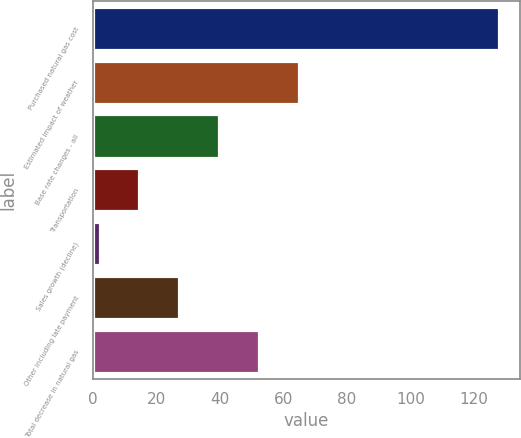<chart> <loc_0><loc_0><loc_500><loc_500><bar_chart><fcel>Purchased natural gas cost<fcel>Estimated impact of weather<fcel>Base rate changes - all<fcel>Transportation<fcel>Sales growth (decline)<fcel>Other including late payment<fcel>Total decrease in natural gas<nl><fcel>128<fcel>65<fcel>39.8<fcel>14.6<fcel>2<fcel>27.2<fcel>52.4<nl></chart> 